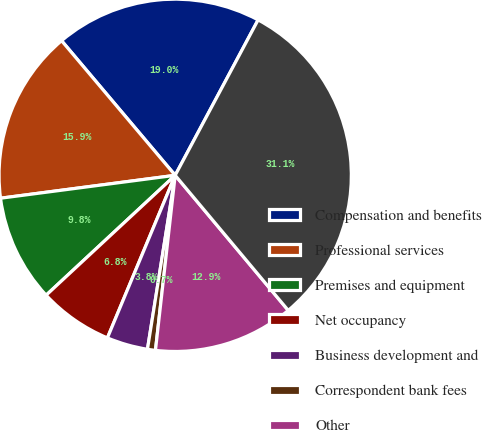<chart> <loc_0><loc_0><loc_500><loc_500><pie_chart><fcel>Compensation and benefits<fcel>Professional services<fcel>Premises and equipment<fcel>Net occupancy<fcel>Business development and<fcel>Correspondent bank fees<fcel>Other<fcel>Total noninterest expense<nl><fcel>18.96%<fcel>15.92%<fcel>9.84%<fcel>6.8%<fcel>3.77%<fcel>0.73%<fcel>12.88%<fcel>31.11%<nl></chart> 